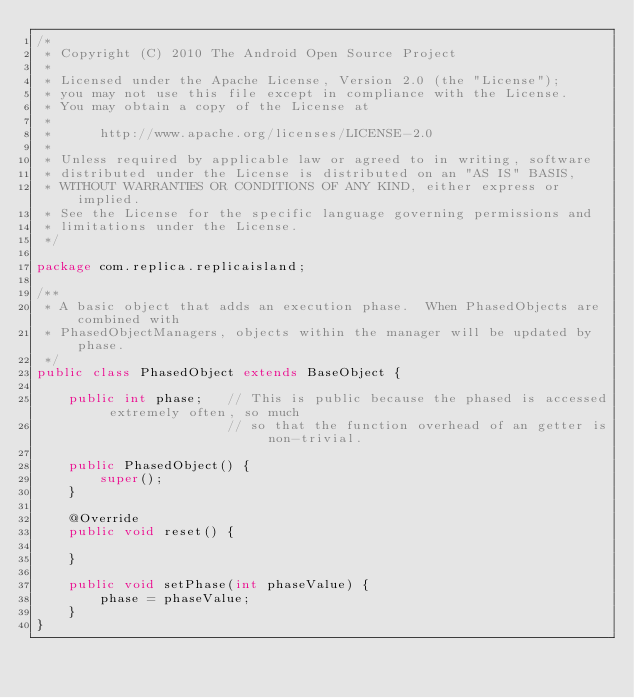Convert code to text. <code><loc_0><loc_0><loc_500><loc_500><_Java_>/*
 * Copyright (C) 2010 The Android Open Source Project
 *
 * Licensed under the Apache License, Version 2.0 (the "License");
 * you may not use this file except in compliance with the License.
 * You may obtain a copy of the License at
 *
 *      http://www.apache.org/licenses/LICENSE-2.0
 *
 * Unless required by applicable law or agreed to in writing, software
 * distributed under the License is distributed on an "AS IS" BASIS,
 * WITHOUT WARRANTIES OR CONDITIONS OF ANY KIND, either express or implied.
 * See the License for the specific language governing permissions and
 * limitations under the License.
 */

package com.replica.replicaisland;

/**
 * A basic object that adds an execution phase.  When PhasedObjects are combined with
 * PhasedObjectManagers, objects within the manager will be updated by phase.
 */
public class PhasedObject extends BaseObject {

    public int phase;   // This is public because the phased is accessed extremely often, so much
                        // so that the function overhead of an getter is non-trivial.  

    public PhasedObject() {
        super();
    }
    
    @Override
    public void reset() {
        
    }

    public void setPhase(int phaseValue) {
        phase = phaseValue;
    }
}
</code> 